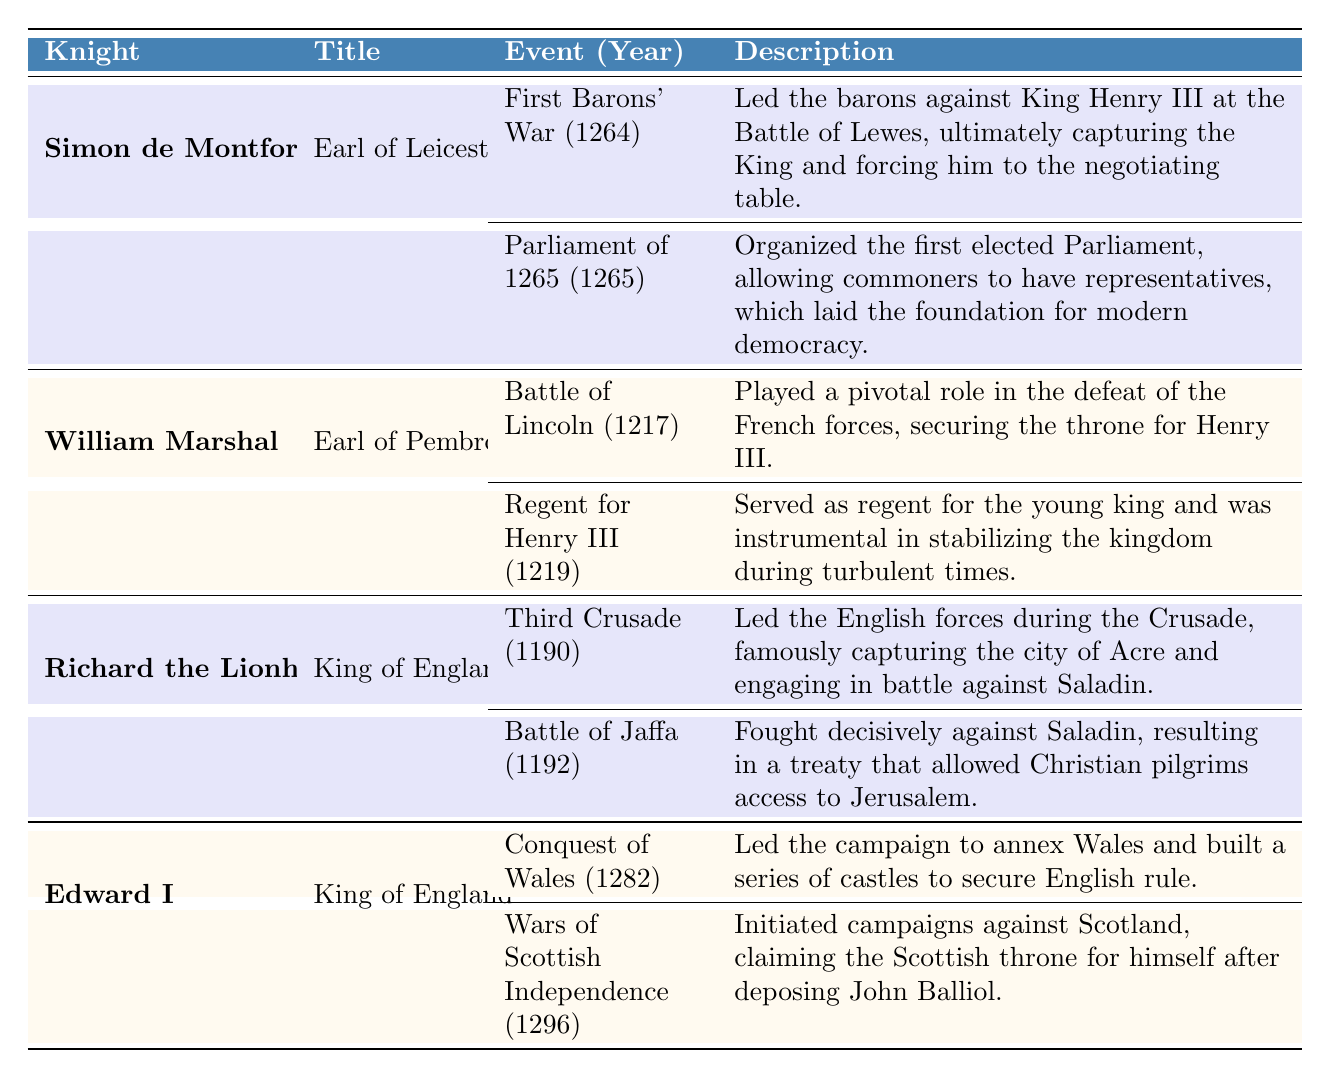What were the notable deeds of Simon de Montfort? According to the table, Simon de Montfort's notable deeds include leading the barons in the First Barons' War in 1264 and organizing the Parliament of 1265.
Answer: First Barons' War (1264), Parliament of 1265 Which knight was involved in the Battle of Lincoln in 1217? The table lists William Marshal as the knight who played a pivotal role in the Battle of Lincoln in 1217.
Answer: William Marshal Did Edward I lead the campaigns against Scotland? Yes, the table indicates that Edward I initiated campaigns against Scotland in 1296 during the Wars of Scottish Independence.
Answer: Yes How many events are listed for Richard the Lionheart? The table provides two events under Richard the Lionheart: the Third Crusade in 1190 and the Battle of Jaffa in 1192.
Answer: 2 Which knight served as regent for Henry III, and in what year? The table shows that William Marshal served as regent for Henry III in the year 1219.
Answer: William Marshal, 1219 What is the year associated with the Conquest of Wales? The table states that the Conquest of Wales occurred in 1282, as led by Edward I.
Answer: 1282 Did Simon de Montfort participate in the Third Crusade? No, the table does not list Simon de Montfort as having participated in the Third Crusade, which is associated with Richard the Lionheart.
Answer: No What year did the Parliament of 1265 take place, and what was its significance? According to the table, the Parliament of 1265 took place in the same year and was significant for being the first elected Parliament, allowing commoners to have representatives.
Answer: 1265, first elected Parliament What were the titles held by Richard the Lionheart? The table indicates that Richard the Lionheart held the title of King of England.
Answer: King of England What are the years of notable deeds for Edward I? The table lists two events for Edward I: Conquest of Wales in 1282 and Wars of Scottish Independence in 1296.
Answer: 1282, 1296 